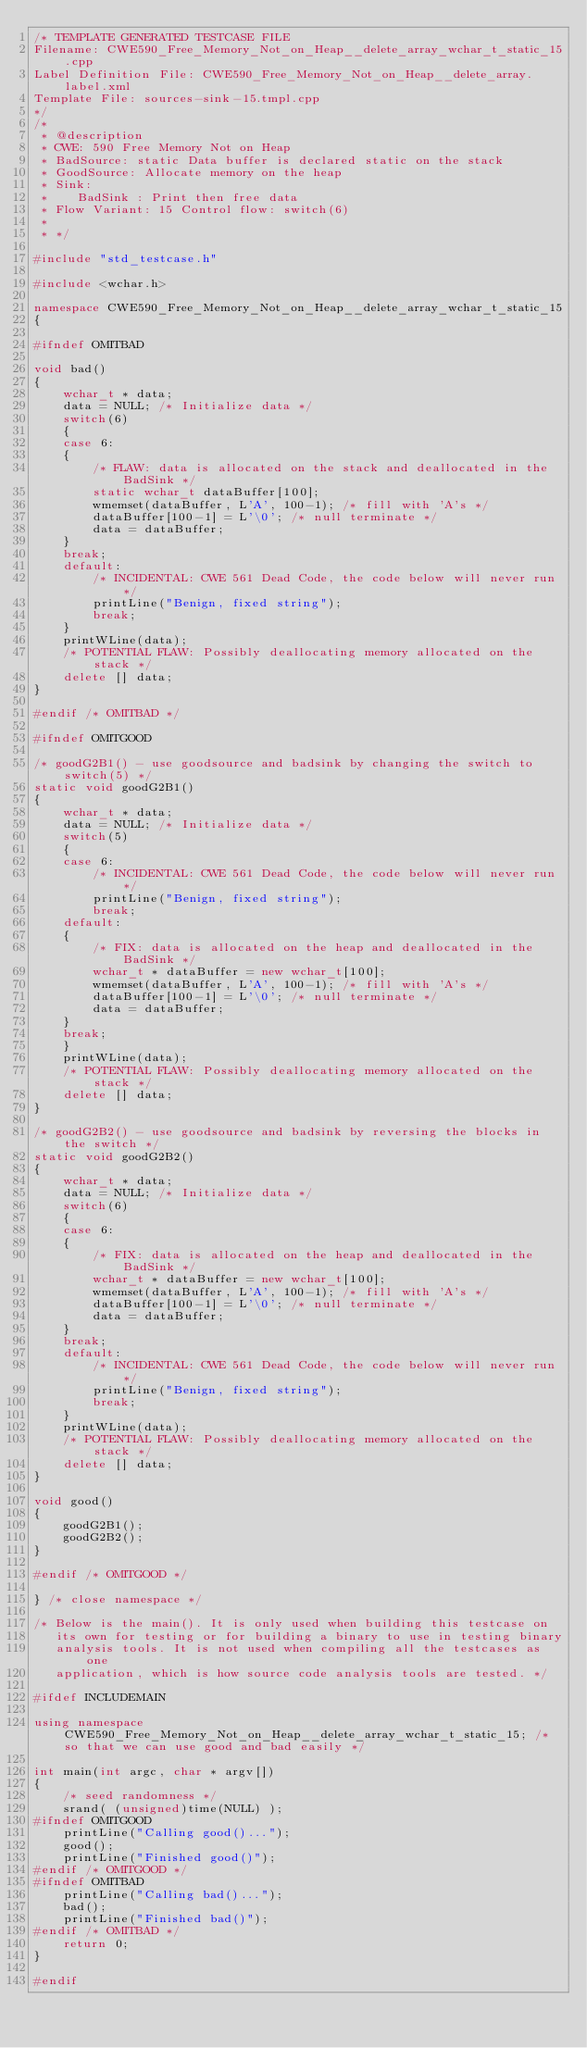Convert code to text. <code><loc_0><loc_0><loc_500><loc_500><_C++_>/* TEMPLATE GENERATED TESTCASE FILE
Filename: CWE590_Free_Memory_Not_on_Heap__delete_array_wchar_t_static_15.cpp
Label Definition File: CWE590_Free_Memory_Not_on_Heap__delete_array.label.xml
Template File: sources-sink-15.tmpl.cpp
*/
/*
 * @description
 * CWE: 590 Free Memory Not on Heap
 * BadSource: static Data buffer is declared static on the stack
 * GoodSource: Allocate memory on the heap
 * Sink:
 *    BadSink : Print then free data
 * Flow Variant: 15 Control flow: switch(6)
 *
 * */

#include "std_testcase.h"

#include <wchar.h>

namespace CWE590_Free_Memory_Not_on_Heap__delete_array_wchar_t_static_15
{

#ifndef OMITBAD

void bad()
{
    wchar_t * data;
    data = NULL; /* Initialize data */
    switch(6)
    {
    case 6:
    {
        /* FLAW: data is allocated on the stack and deallocated in the BadSink */
        static wchar_t dataBuffer[100];
        wmemset(dataBuffer, L'A', 100-1); /* fill with 'A's */
        dataBuffer[100-1] = L'\0'; /* null terminate */
        data = dataBuffer;
    }
    break;
    default:
        /* INCIDENTAL: CWE 561 Dead Code, the code below will never run */
        printLine("Benign, fixed string");
        break;
    }
    printWLine(data);
    /* POTENTIAL FLAW: Possibly deallocating memory allocated on the stack */
    delete [] data;
}

#endif /* OMITBAD */

#ifndef OMITGOOD

/* goodG2B1() - use goodsource and badsink by changing the switch to switch(5) */
static void goodG2B1()
{
    wchar_t * data;
    data = NULL; /* Initialize data */
    switch(5)
    {
    case 6:
        /* INCIDENTAL: CWE 561 Dead Code, the code below will never run */
        printLine("Benign, fixed string");
        break;
    default:
    {
        /* FIX: data is allocated on the heap and deallocated in the BadSink */
        wchar_t * dataBuffer = new wchar_t[100];
        wmemset(dataBuffer, L'A', 100-1); /* fill with 'A's */
        dataBuffer[100-1] = L'\0'; /* null terminate */
        data = dataBuffer;
    }
    break;
    }
    printWLine(data);
    /* POTENTIAL FLAW: Possibly deallocating memory allocated on the stack */
    delete [] data;
}

/* goodG2B2() - use goodsource and badsink by reversing the blocks in the switch */
static void goodG2B2()
{
    wchar_t * data;
    data = NULL; /* Initialize data */
    switch(6)
    {
    case 6:
    {
        /* FIX: data is allocated on the heap and deallocated in the BadSink */
        wchar_t * dataBuffer = new wchar_t[100];
        wmemset(dataBuffer, L'A', 100-1); /* fill with 'A's */
        dataBuffer[100-1] = L'\0'; /* null terminate */
        data = dataBuffer;
    }
    break;
    default:
        /* INCIDENTAL: CWE 561 Dead Code, the code below will never run */
        printLine("Benign, fixed string");
        break;
    }
    printWLine(data);
    /* POTENTIAL FLAW: Possibly deallocating memory allocated on the stack */
    delete [] data;
}

void good()
{
    goodG2B1();
    goodG2B2();
}

#endif /* OMITGOOD */

} /* close namespace */

/* Below is the main(). It is only used when building this testcase on
   its own for testing or for building a binary to use in testing binary
   analysis tools. It is not used when compiling all the testcases as one
   application, which is how source code analysis tools are tested. */

#ifdef INCLUDEMAIN

using namespace CWE590_Free_Memory_Not_on_Heap__delete_array_wchar_t_static_15; /* so that we can use good and bad easily */

int main(int argc, char * argv[])
{
    /* seed randomness */
    srand( (unsigned)time(NULL) );
#ifndef OMITGOOD
    printLine("Calling good()...");
    good();
    printLine("Finished good()");
#endif /* OMITGOOD */
#ifndef OMITBAD
    printLine("Calling bad()...");
    bad();
    printLine("Finished bad()");
#endif /* OMITBAD */
    return 0;
}

#endif
</code> 